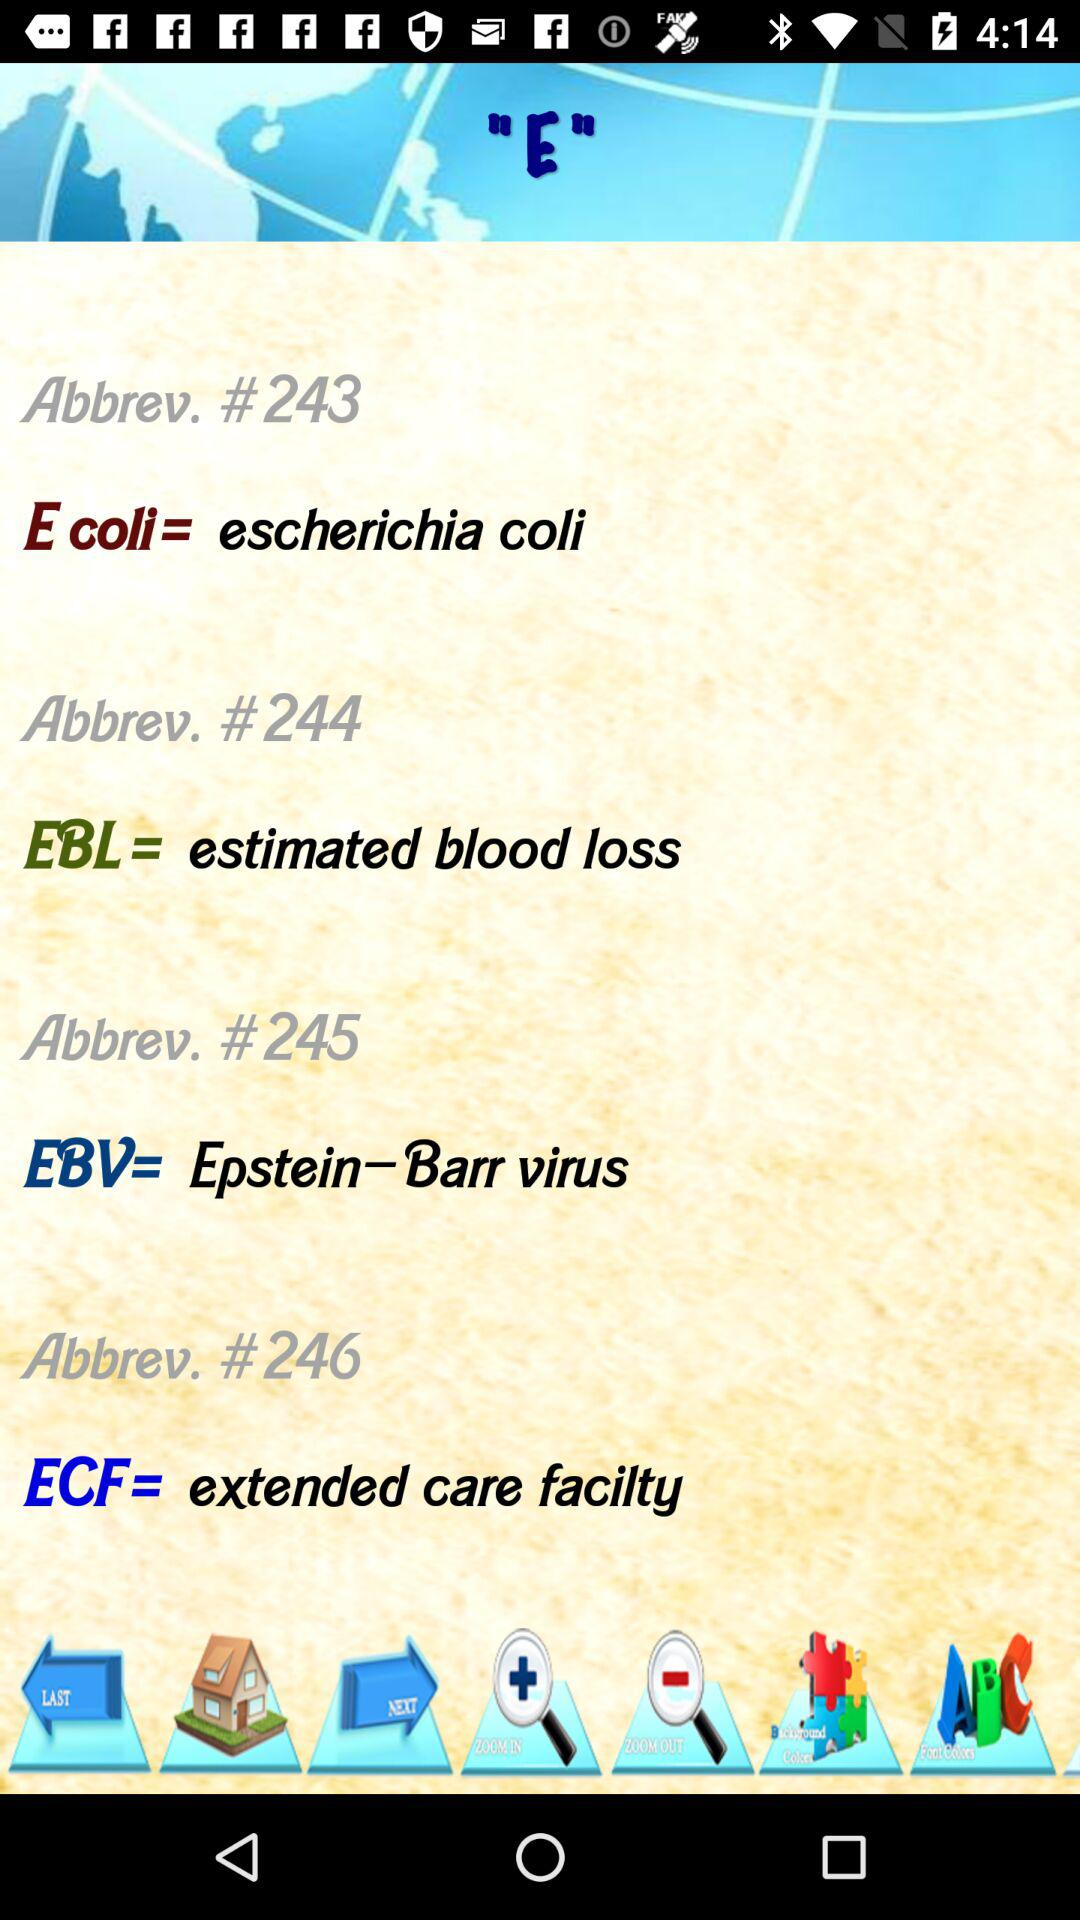What is the full form of E. coli? The full form of E. coli is "escherichia coli". 